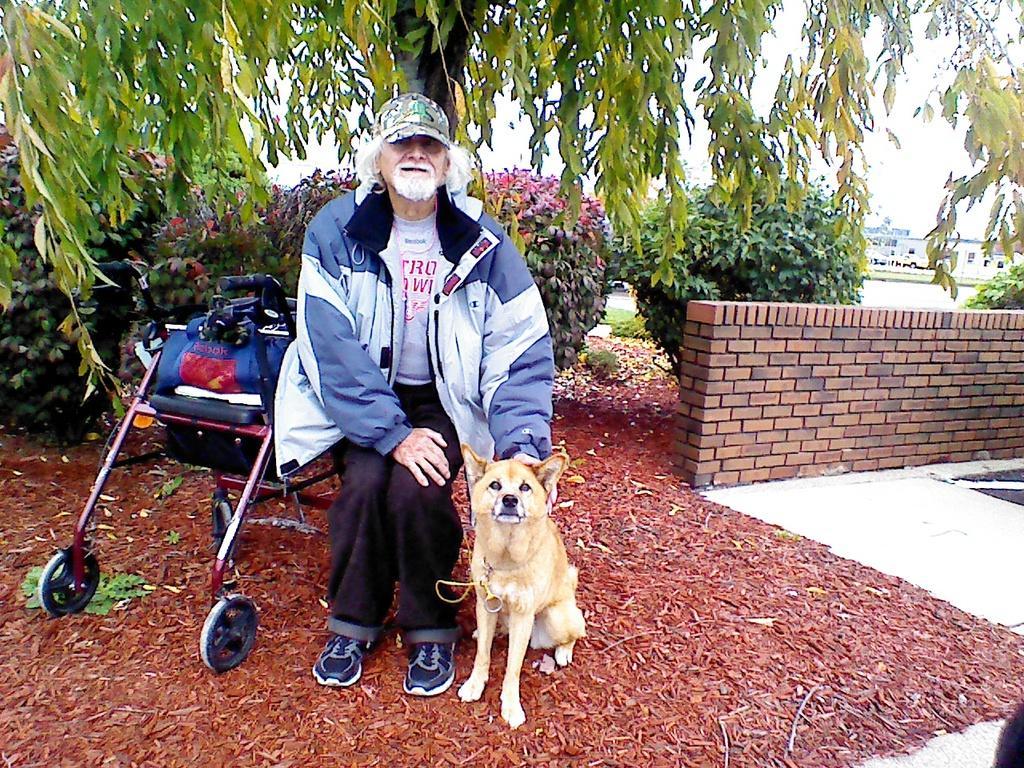How would you summarize this image in a sentence or two? In this image we can see a man wearing a cap and a jacket sitting on the chair. Beside the man we can see a dog sitting on the ground. Behind the man we can see a tree and few plants. We have a wall made of bricks. 